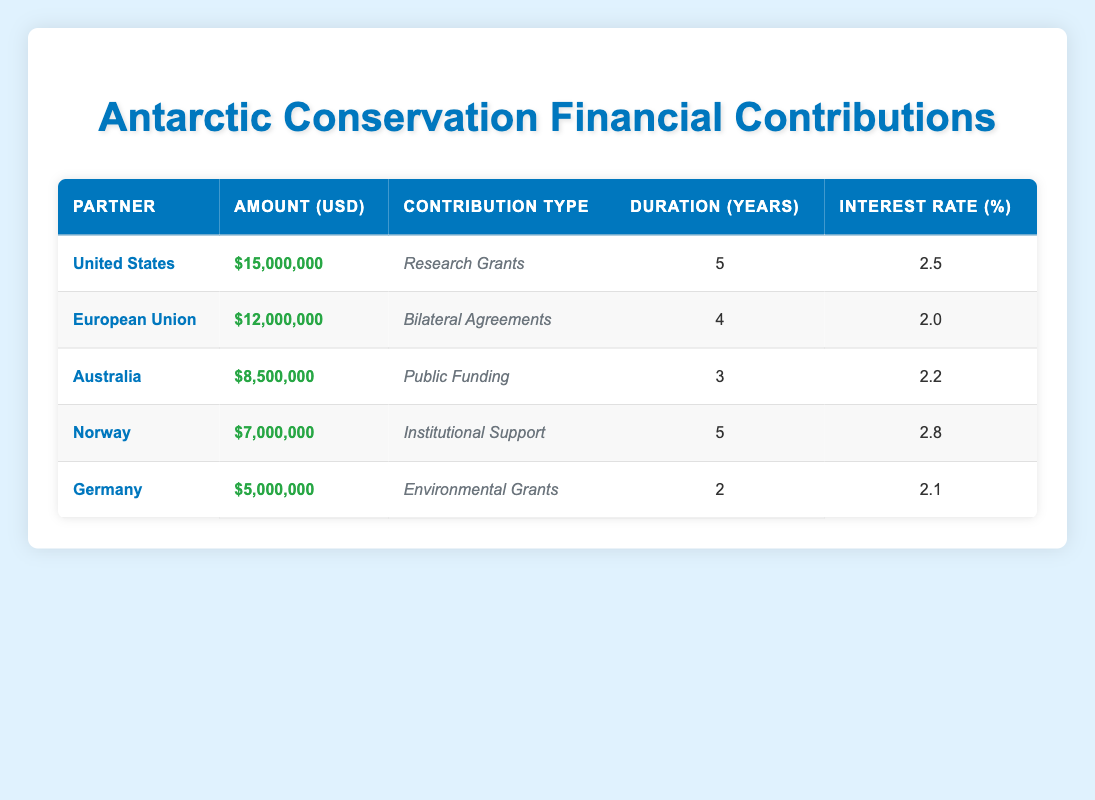What is the total amount of financial contributions from all partners? To find the total contribution, add the amounts: 15,000,000 + 12,000,000 + 8,500,000 + 7,000,000 + 5,000,000 = 47,500,000.
Answer: 47,500,000 Which partner has the highest amount of contributions? The partner with the highest amount is the United States, contributing 15,000,000, which is the largest figure compared to the others listed.
Answer: United States Is the interest rate for Norway higher than that of Germany? Norway has an interest rate of 2.8%, while Germany has an interest rate of 2.1%. Since 2.8% is greater than 2.1%, the statement is true.
Answer: Yes What is the average duration of contributions from all partners? To find the average duration, sum the durations: 5 + 4 + 3 + 5 + 2 = 19, then divide by the number of partners (5): 19 / 5 = 3.8.
Answer: 3.8 How much is the financial contribution from the European Union compared to Australia? The European Union contributes 12,000,000 while Australia contributes 8,500,000. Comparing these amounts, 12,000,000 is greater than 8,500,000.
Answer: European Union contributes more than Australia What is the total amount contributed by partners with a duration of 5 years? The partners with a duration of 5 years are the United States (15,000,000) and Norway (7,000,000). Summing these amounts gives 15,000,000 + 7,000,000 = 22,000,000.
Answer: 22,000,000 Are there any partners contributing less than 8 million? Germany (5,000,000) is the only partner below 8 million as both Australia and Norway's contributions exceed this amount.
Answer: Yes Which contribution type has the lowest interest rate? The contribution types range from 2.0% to 2.8%, and the European Union has the lowest interest rate at 2.0%.
Answer: Bilateral Agreements 